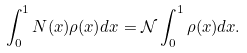<formula> <loc_0><loc_0><loc_500><loc_500>\int _ { 0 } ^ { 1 } N ( x ) \rho ( x ) d x = { \mathcal { N } } \int _ { 0 } ^ { 1 } \rho ( x ) d x .</formula> 